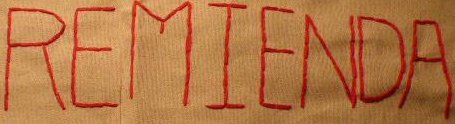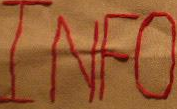What words are shown in these images in order, separated by a semicolon? REMIENDA; INFO 